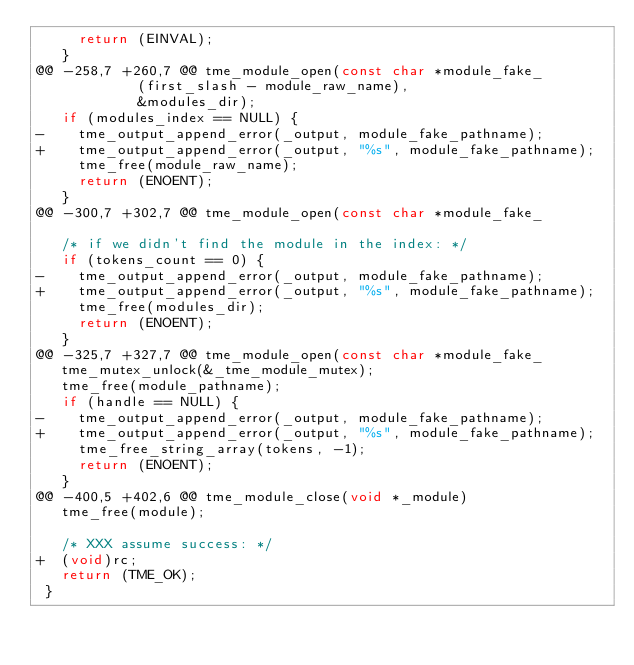Convert code to text. <code><loc_0><loc_0><loc_500><loc_500><_C_>     return (EINVAL);
   }
@@ -258,7 +260,7 @@ tme_module_open(const char *module_fake_
 				    (first_slash - module_raw_name),
 				    &modules_dir);
   if (modules_index == NULL) {
-    tme_output_append_error(_output, module_fake_pathname);
+    tme_output_append_error(_output, "%s", module_fake_pathname);
     tme_free(module_raw_name);
     return (ENOENT);
   }
@@ -300,7 +302,7 @@ tme_module_open(const char *module_fake_
 
   /* if we didn't find the module in the index: */
   if (tokens_count == 0) {
-    tme_output_append_error(_output, module_fake_pathname);
+    tme_output_append_error(_output, "%s", module_fake_pathname);
     tme_free(modules_dir);
     return (ENOENT);
   }
@@ -325,7 +327,7 @@ tme_module_open(const char *module_fake_
   tme_mutex_unlock(&_tme_module_mutex);
   tme_free(module_pathname);
   if (handle == NULL) {
-    tme_output_append_error(_output, module_fake_pathname);
+    tme_output_append_error(_output, "%s", module_fake_pathname);
     tme_free_string_array(tokens, -1);
     return (ENOENT);
   }
@@ -400,5 +402,6 @@ tme_module_close(void *_module)
   tme_free(module);
 
   /* XXX assume success: */
+  (void)rc;
   return (TME_OK);
 }
</code> 